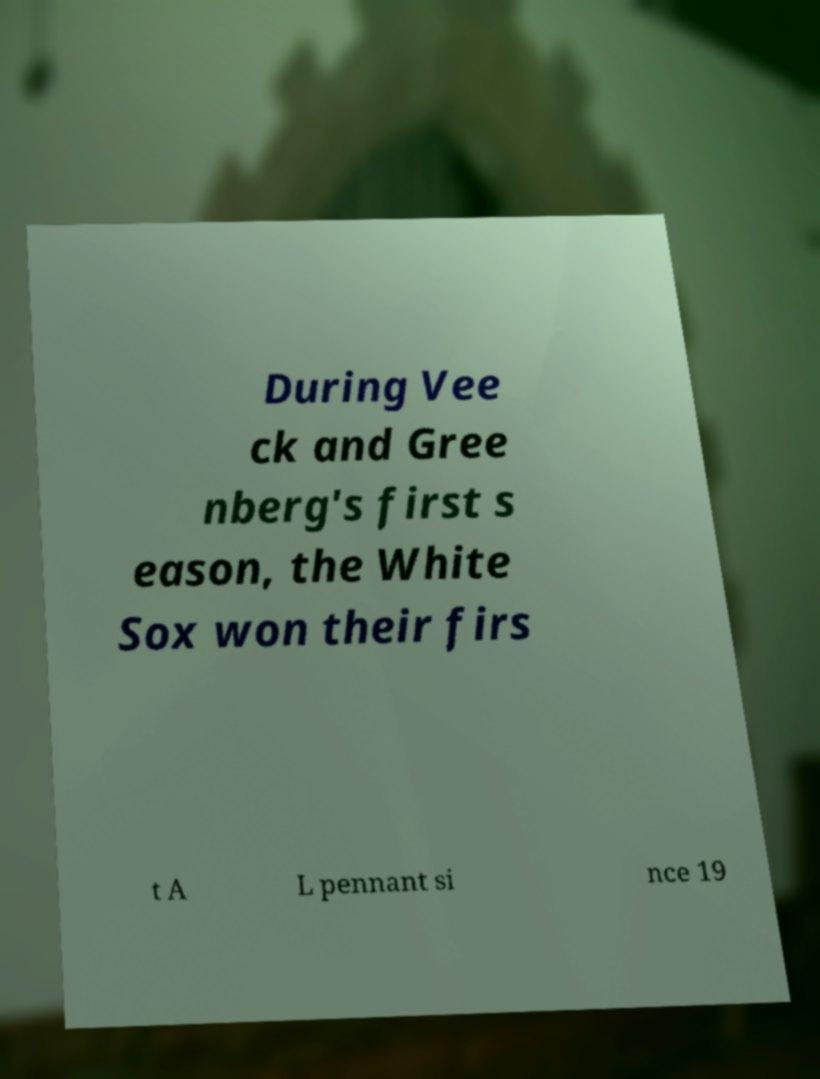There's text embedded in this image that I need extracted. Can you transcribe it verbatim? During Vee ck and Gree nberg's first s eason, the White Sox won their firs t A L pennant si nce 19 